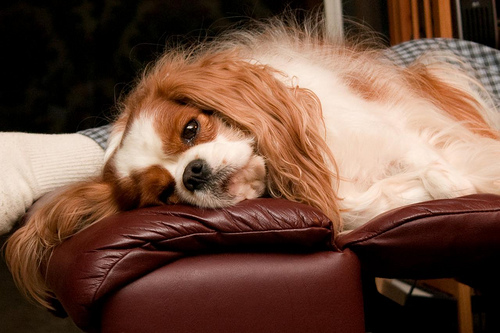<image>
Can you confirm if the dog is on the couch? Yes. Looking at the image, I can see the dog is positioned on top of the couch, with the couch providing support. Is there a dog behind the couch? No. The dog is not behind the couch. From this viewpoint, the dog appears to be positioned elsewhere in the scene. 